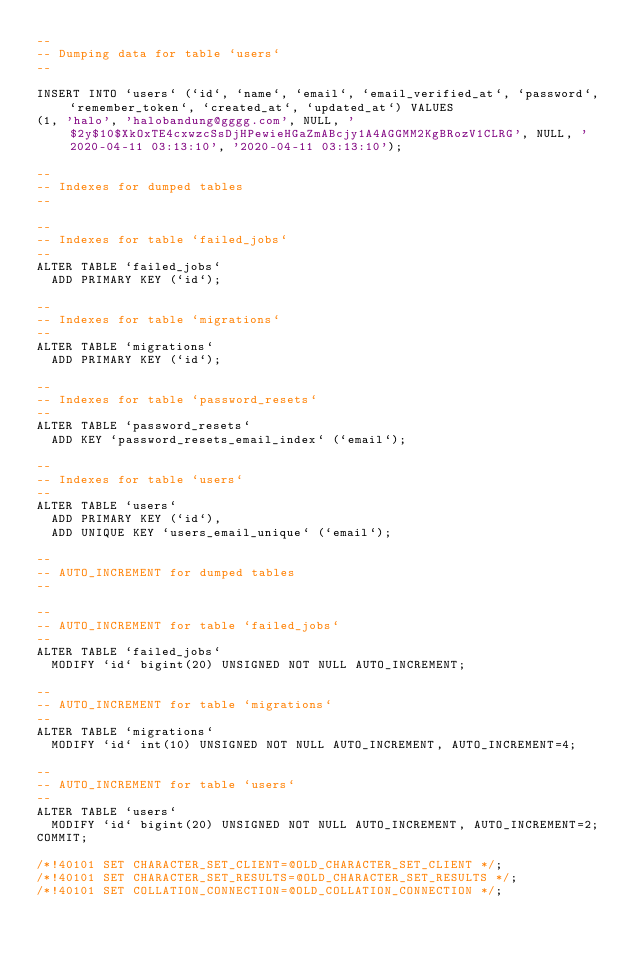<code> <loc_0><loc_0><loc_500><loc_500><_SQL_>--
-- Dumping data for table `users`
--

INSERT INTO `users` (`id`, `name`, `email`, `email_verified_at`, `password`, `remember_token`, `created_at`, `updated_at`) VALUES
(1, 'halo', 'halobandung@gggg.com', NULL, '$2y$10$XkOxTE4cxwzcSsDjHPewieHGaZmABcjy1A4AGGMM2KgBRozV1CLRG', NULL, '2020-04-11 03:13:10', '2020-04-11 03:13:10');

--
-- Indexes for dumped tables
--

--
-- Indexes for table `failed_jobs`
--
ALTER TABLE `failed_jobs`
  ADD PRIMARY KEY (`id`);

--
-- Indexes for table `migrations`
--
ALTER TABLE `migrations`
  ADD PRIMARY KEY (`id`);

--
-- Indexes for table `password_resets`
--
ALTER TABLE `password_resets`
  ADD KEY `password_resets_email_index` (`email`);

--
-- Indexes for table `users`
--
ALTER TABLE `users`
  ADD PRIMARY KEY (`id`),
  ADD UNIQUE KEY `users_email_unique` (`email`);

--
-- AUTO_INCREMENT for dumped tables
--

--
-- AUTO_INCREMENT for table `failed_jobs`
--
ALTER TABLE `failed_jobs`
  MODIFY `id` bigint(20) UNSIGNED NOT NULL AUTO_INCREMENT;

--
-- AUTO_INCREMENT for table `migrations`
--
ALTER TABLE `migrations`
  MODIFY `id` int(10) UNSIGNED NOT NULL AUTO_INCREMENT, AUTO_INCREMENT=4;

--
-- AUTO_INCREMENT for table `users`
--
ALTER TABLE `users`
  MODIFY `id` bigint(20) UNSIGNED NOT NULL AUTO_INCREMENT, AUTO_INCREMENT=2;
COMMIT;

/*!40101 SET CHARACTER_SET_CLIENT=@OLD_CHARACTER_SET_CLIENT */;
/*!40101 SET CHARACTER_SET_RESULTS=@OLD_CHARACTER_SET_RESULTS */;
/*!40101 SET COLLATION_CONNECTION=@OLD_COLLATION_CONNECTION */;
</code> 